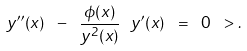<formula> <loc_0><loc_0><loc_500><loc_500>y ^ { \prime \prime } ( x ) \ - \ \frac { \phi ( x ) } { y ^ { 2 } ( x ) } \ y ^ { \prime } ( x ) \ = \ 0 \ > .</formula> 